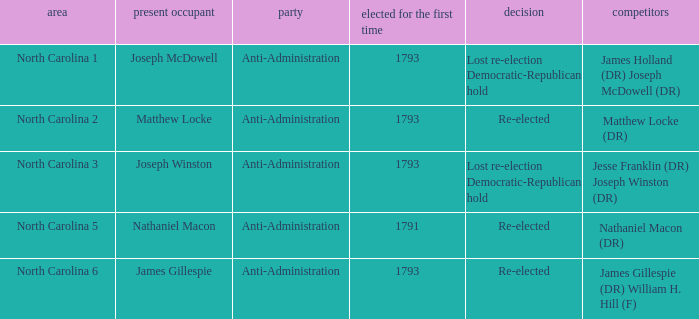Who was the candidate in 1791? Nathaniel Macon (DR). 